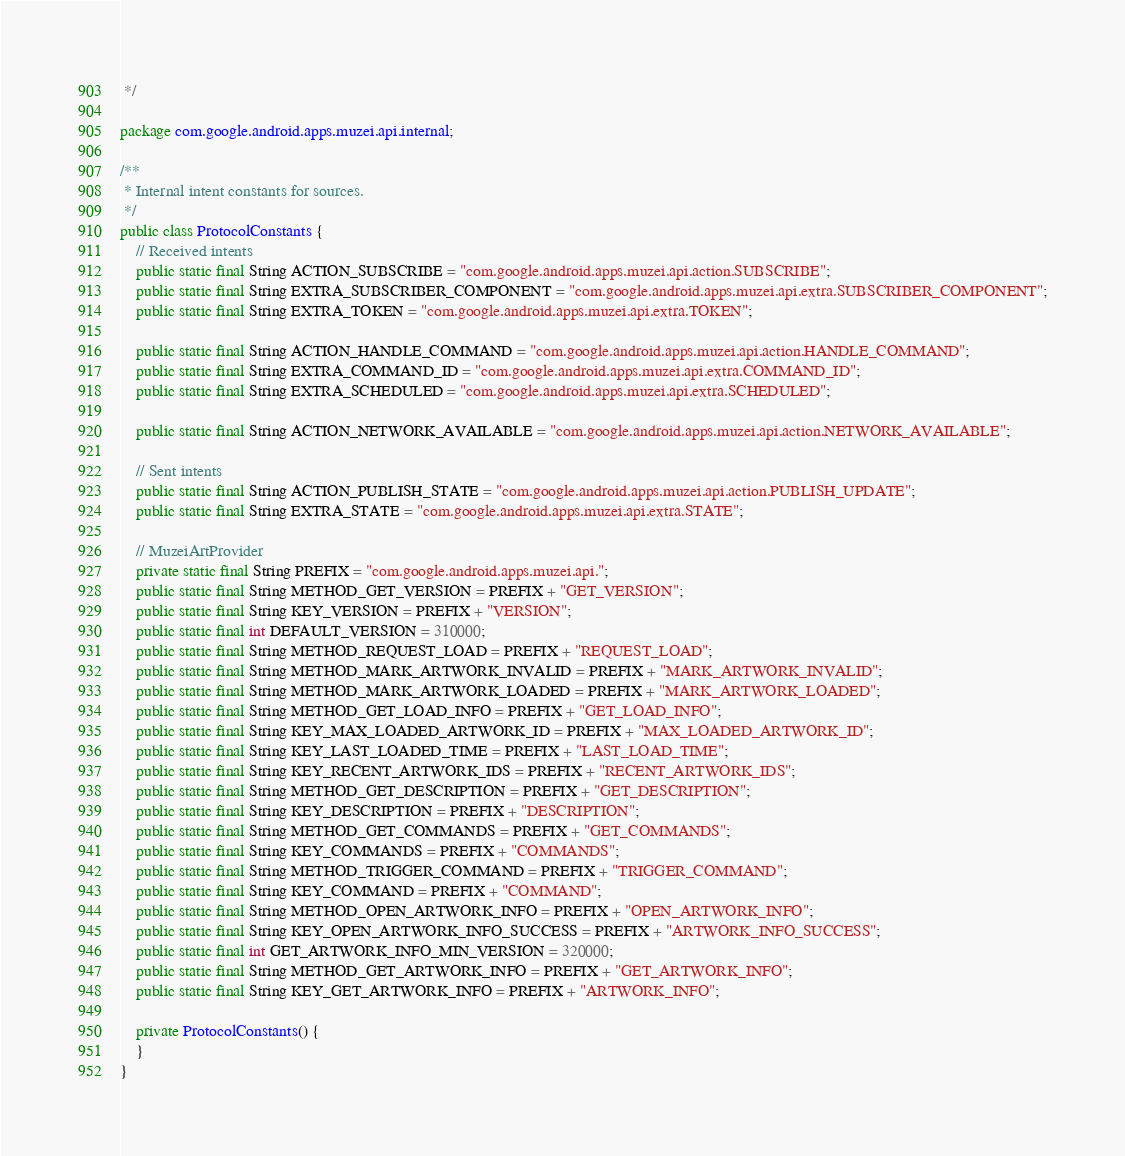Convert code to text. <code><loc_0><loc_0><loc_500><loc_500><_Java_> */

package com.google.android.apps.muzei.api.internal;

/**
 * Internal intent constants for sources.
 */
public class ProtocolConstants {
    // Received intents
    public static final String ACTION_SUBSCRIBE = "com.google.android.apps.muzei.api.action.SUBSCRIBE";
    public static final String EXTRA_SUBSCRIBER_COMPONENT = "com.google.android.apps.muzei.api.extra.SUBSCRIBER_COMPONENT";
    public static final String EXTRA_TOKEN = "com.google.android.apps.muzei.api.extra.TOKEN";

    public static final String ACTION_HANDLE_COMMAND = "com.google.android.apps.muzei.api.action.HANDLE_COMMAND";
    public static final String EXTRA_COMMAND_ID = "com.google.android.apps.muzei.api.extra.COMMAND_ID";
    public static final String EXTRA_SCHEDULED = "com.google.android.apps.muzei.api.extra.SCHEDULED";

    public static final String ACTION_NETWORK_AVAILABLE = "com.google.android.apps.muzei.api.action.NETWORK_AVAILABLE";

    // Sent intents
    public static final String ACTION_PUBLISH_STATE = "com.google.android.apps.muzei.api.action.PUBLISH_UPDATE";
    public static final String EXTRA_STATE = "com.google.android.apps.muzei.api.extra.STATE";

    // MuzeiArtProvider
    private static final String PREFIX = "com.google.android.apps.muzei.api.";
    public static final String METHOD_GET_VERSION = PREFIX + "GET_VERSION";
    public static final String KEY_VERSION = PREFIX + "VERSION";
    public static final int DEFAULT_VERSION = 310000;
    public static final String METHOD_REQUEST_LOAD = PREFIX + "REQUEST_LOAD";
    public static final String METHOD_MARK_ARTWORK_INVALID = PREFIX + "MARK_ARTWORK_INVALID";
    public static final String METHOD_MARK_ARTWORK_LOADED = PREFIX + "MARK_ARTWORK_LOADED";
    public static final String METHOD_GET_LOAD_INFO = PREFIX + "GET_LOAD_INFO";
    public static final String KEY_MAX_LOADED_ARTWORK_ID = PREFIX + "MAX_LOADED_ARTWORK_ID";
    public static final String KEY_LAST_LOADED_TIME = PREFIX + "LAST_LOAD_TIME";
    public static final String KEY_RECENT_ARTWORK_IDS = PREFIX + "RECENT_ARTWORK_IDS";
    public static final String METHOD_GET_DESCRIPTION = PREFIX + "GET_DESCRIPTION";
    public static final String KEY_DESCRIPTION = PREFIX + "DESCRIPTION";
    public static final String METHOD_GET_COMMANDS = PREFIX + "GET_COMMANDS";
    public static final String KEY_COMMANDS = PREFIX + "COMMANDS";
    public static final String METHOD_TRIGGER_COMMAND = PREFIX + "TRIGGER_COMMAND";
    public static final String KEY_COMMAND = PREFIX + "COMMAND";
    public static final String METHOD_OPEN_ARTWORK_INFO = PREFIX + "OPEN_ARTWORK_INFO";
    public static final String KEY_OPEN_ARTWORK_INFO_SUCCESS = PREFIX + "ARTWORK_INFO_SUCCESS";
    public static final int GET_ARTWORK_INFO_MIN_VERSION = 320000;
    public static final String METHOD_GET_ARTWORK_INFO = PREFIX + "GET_ARTWORK_INFO";
    public static final String KEY_GET_ARTWORK_INFO = PREFIX + "ARTWORK_INFO";

    private ProtocolConstants() {
    }
}
</code> 